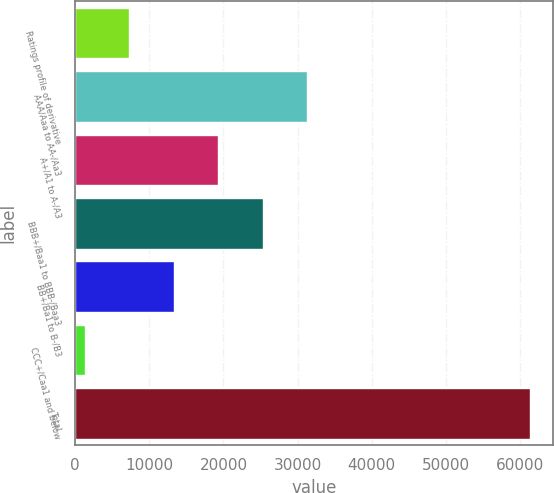Convert chart to OTSL. <chart><loc_0><loc_0><loc_500><loc_500><bar_chart><fcel>Ratings profile of derivative<fcel>AAA/Aaa to AA-/Aa3<fcel>A+/A1 to A-/A3<fcel>BBB+/Baa1 to BBB-/Baa3<fcel>BB+/Ba1 to B-/B3<fcel>CCC+/Caa1 and below<fcel>Total<nl><fcel>7287.2<fcel>31304<fcel>19295.6<fcel>25299.8<fcel>13291.4<fcel>1283<fcel>61325<nl></chart> 